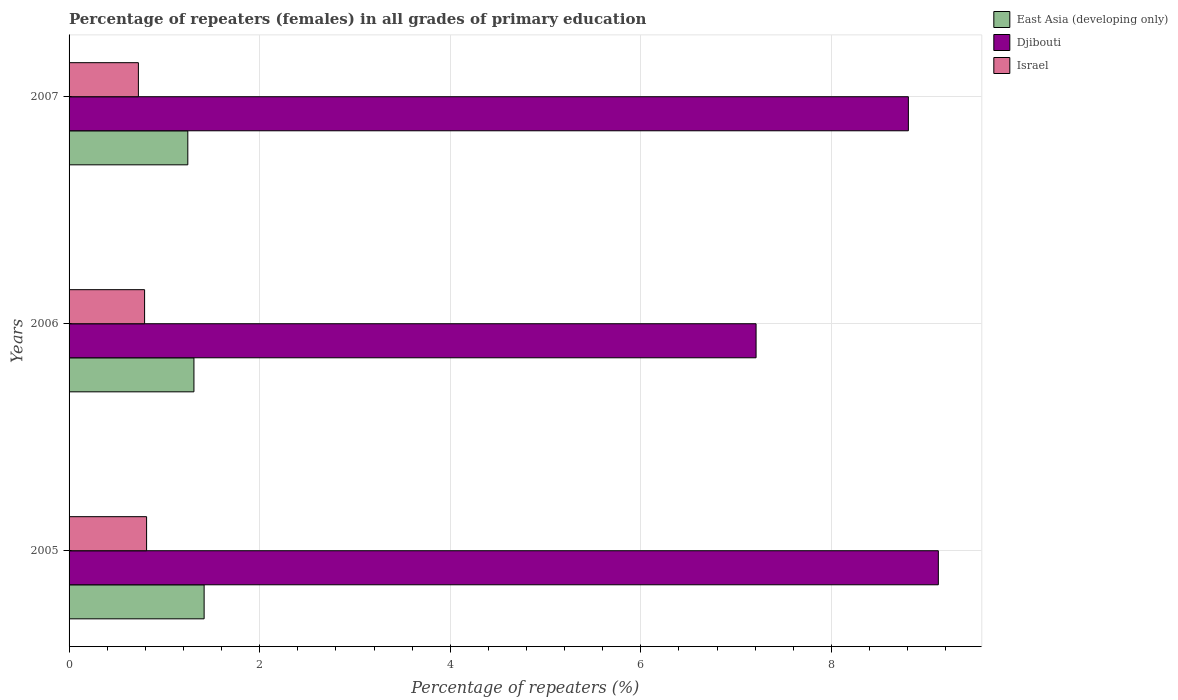How many different coloured bars are there?
Your response must be concise. 3. Are the number of bars per tick equal to the number of legend labels?
Give a very brief answer. Yes. How many bars are there on the 1st tick from the bottom?
Ensure brevity in your answer.  3. What is the percentage of repeaters (females) in Israel in 2007?
Your answer should be compact. 0.73. Across all years, what is the maximum percentage of repeaters (females) in East Asia (developing only)?
Provide a succinct answer. 1.42. Across all years, what is the minimum percentage of repeaters (females) in East Asia (developing only)?
Your answer should be very brief. 1.25. What is the total percentage of repeaters (females) in Djibouti in the graph?
Your answer should be very brief. 25.14. What is the difference between the percentage of repeaters (females) in Israel in 2005 and that in 2006?
Keep it short and to the point. 0.02. What is the difference between the percentage of repeaters (females) in East Asia (developing only) in 2006 and the percentage of repeaters (females) in Israel in 2005?
Your response must be concise. 0.5. What is the average percentage of repeaters (females) in Djibouti per year?
Make the answer very short. 8.38. In the year 2006, what is the difference between the percentage of repeaters (females) in Israel and percentage of repeaters (females) in Djibouti?
Give a very brief answer. -6.42. What is the ratio of the percentage of repeaters (females) in Israel in 2006 to that in 2007?
Offer a terse response. 1.09. Is the difference between the percentage of repeaters (females) in Israel in 2005 and 2006 greater than the difference between the percentage of repeaters (females) in Djibouti in 2005 and 2006?
Your answer should be compact. No. What is the difference between the highest and the second highest percentage of repeaters (females) in East Asia (developing only)?
Your response must be concise. 0.11. What is the difference between the highest and the lowest percentage of repeaters (females) in Israel?
Offer a terse response. 0.09. What does the 3rd bar from the top in 2007 represents?
Your answer should be compact. East Asia (developing only). What does the 2nd bar from the bottom in 2007 represents?
Keep it short and to the point. Djibouti. Are all the bars in the graph horizontal?
Provide a succinct answer. Yes. What is the difference between two consecutive major ticks on the X-axis?
Keep it short and to the point. 2. Are the values on the major ticks of X-axis written in scientific E-notation?
Ensure brevity in your answer.  No. Does the graph contain any zero values?
Make the answer very short. No. Does the graph contain grids?
Your answer should be very brief. Yes. Where does the legend appear in the graph?
Make the answer very short. Top right. How are the legend labels stacked?
Your answer should be very brief. Vertical. What is the title of the graph?
Your answer should be compact. Percentage of repeaters (females) in all grades of primary education. What is the label or title of the X-axis?
Your response must be concise. Percentage of repeaters (%). What is the label or title of the Y-axis?
Give a very brief answer. Years. What is the Percentage of repeaters (%) in East Asia (developing only) in 2005?
Make the answer very short. 1.42. What is the Percentage of repeaters (%) in Djibouti in 2005?
Offer a very short reply. 9.12. What is the Percentage of repeaters (%) of Israel in 2005?
Ensure brevity in your answer.  0.81. What is the Percentage of repeaters (%) of East Asia (developing only) in 2006?
Make the answer very short. 1.31. What is the Percentage of repeaters (%) of Djibouti in 2006?
Provide a succinct answer. 7.21. What is the Percentage of repeaters (%) in Israel in 2006?
Ensure brevity in your answer.  0.79. What is the Percentage of repeaters (%) in East Asia (developing only) in 2007?
Make the answer very short. 1.25. What is the Percentage of repeaters (%) in Djibouti in 2007?
Give a very brief answer. 8.81. What is the Percentage of repeaters (%) in Israel in 2007?
Offer a terse response. 0.73. Across all years, what is the maximum Percentage of repeaters (%) in East Asia (developing only)?
Make the answer very short. 1.42. Across all years, what is the maximum Percentage of repeaters (%) in Djibouti?
Make the answer very short. 9.12. Across all years, what is the maximum Percentage of repeaters (%) in Israel?
Your answer should be very brief. 0.81. Across all years, what is the minimum Percentage of repeaters (%) in East Asia (developing only)?
Your answer should be compact. 1.25. Across all years, what is the minimum Percentage of repeaters (%) in Djibouti?
Your response must be concise. 7.21. Across all years, what is the minimum Percentage of repeaters (%) in Israel?
Make the answer very short. 0.73. What is the total Percentage of repeaters (%) in East Asia (developing only) in the graph?
Give a very brief answer. 3.97. What is the total Percentage of repeaters (%) in Djibouti in the graph?
Offer a terse response. 25.14. What is the total Percentage of repeaters (%) of Israel in the graph?
Offer a very short reply. 2.33. What is the difference between the Percentage of repeaters (%) of East Asia (developing only) in 2005 and that in 2006?
Provide a short and direct response. 0.11. What is the difference between the Percentage of repeaters (%) in Djibouti in 2005 and that in 2006?
Offer a terse response. 1.91. What is the difference between the Percentage of repeaters (%) of Israel in 2005 and that in 2006?
Offer a very short reply. 0.02. What is the difference between the Percentage of repeaters (%) of East Asia (developing only) in 2005 and that in 2007?
Your answer should be compact. 0.17. What is the difference between the Percentage of repeaters (%) in Djibouti in 2005 and that in 2007?
Your answer should be very brief. 0.31. What is the difference between the Percentage of repeaters (%) of Israel in 2005 and that in 2007?
Your answer should be compact. 0.09. What is the difference between the Percentage of repeaters (%) of East Asia (developing only) in 2006 and that in 2007?
Your response must be concise. 0.06. What is the difference between the Percentage of repeaters (%) in Djibouti in 2006 and that in 2007?
Your answer should be very brief. -1.6. What is the difference between the Percentage of repeaters (%) in Israel in 2006 and that in 2007?
Provide a succinct answer. 0.07. What is the difference between the Percentage of repeaters (%) in East Asia (developing only) in 2005 and the Percentage of repeaters (%) in Djibouti in 2006?
Your answer should be very brief. -5.79. What is the difference between the Percentage of repeaters (%) in East Asia (developing only) in 2005 and the Percentage of repeaters (%) in Israel in 2006?
Keep it short and to the point. 0.62. What is the difference between the Percentage of repeaters (%) of Djibouti in 2005 and the Percentage of repeaters (%) of Israel in 2006?
Keep it short and to the point. 8.33. What is the difference between the Percentage of repeaters (%) in East Asia (developing only) in 2005 and the Percentage of repeaters (%) in Djibouti in 2007?
Offer a terse response. -7.39. What is the difference between the Percentage of repeaters (%) in East Asia (developing only) in 2005 and the Percentage of repeaters (%) in Israel in 2007?
Your answer should be compact. 0.69. What is the difference between the Percentage of repeaters (%) in Djibouti in 2005 and the Percentage of repeaters (%) in Israel in 2007?
Keep it short and to the point. 8.39. What is the difference between the Percentage of repeaters (%) in East Asia (developing only) in 2006 and the Percentage of repeaters (%) in Djibouti in 2007?
Your answer should be very brief. -7.5. What is the difference between the Percentage of repeaters (%) of East Asia (developing only) in 2006 and the Percentage of repeaters (%) of Israel in 2007?
Ensure brevity in your answer.  0.58. What is the difference between the Percentage of repeaters (%) of Djibouti in 2006 and the Percentage of repeaters (%) of Israel in 2007?
Make the answer very short. 6.48. What is the average Percentage of repeaters (%) in East Asia (developing only) per year?
Ensure brevity in your answer.  1.32. What is the average Percentage of repeaters (%) in Djibouti per year?
Your response must be concise. 8.38. What is the average Percentage of repeaters (%) in Israel per year?
Your response must be concise. 0.78. In the year 2005, what is the difference between the Percentage of repeaters (%) in East Asia (developing only) and Percentage of repeaters (%) in Djibouti?
Ensure brevity in your answer.  -7.71. In the year 2005, what is the difference between the Percentage of repeaters (%) in East Asia (developing only) and Percentage of repeaters (%) in Israel?
Provide a short and direct response. 0.6. In the year 2005, what is the difference between the Percentage of repeaters (%) of Djibouti and Percentage of repeaters (%) of Israel?
Provide a short and direct response. 8.31. In the year 2006, what is the difference between the Percentage of repeaters (%) in East Asia (developing only) and Percentage of repeaters (%) in Djibouti?
Ensure brevity in your answer.  -5.9. In the year 2006, what is the difference between the Percentage of repeaters (%) of East Asia (developing only) and Percentage of repeaters (%) of Israel?
Your response must be concise. 0.52. In the year 2006, what is the difference between the Percentage of repeaters (%) of Djibouti and Percentage of repeaters (%) of Israel?
Make the answer very short. 6.42. In the year 2007, what is the difference between the Percentage of repeaters (%) in East Asia (developing only) and Percentage of repeaters (%) in Djibouti?
Give a very brief answer. -7.56. In the year 2007, what is the difference between the Percentage of repeaters (%) of East Asia (developing only) and Percentage of repeaters (%) of Israel?
Offer a very short reply. 0.52. In the year 2007, what is the difference between the Percentage of repeaters (%) in Djibouti and Percentage of repeaters (%) in Israel?
Give a very brief answer. 8.08. What is the ratio of the Percentage of repeaters (%) in East Asia (developing only) in 2005 to that in 2006?
Offer a very short reply. 1.08. What is the ratio of the Percentage of repeaters (%) in Djibouti in 2005 to that in 2006?
Give a very brief answer. 1.27. What is the ratio of the Percentage of repeaters (%) of Israel in 2005 to that in 2006?
Offer a very short reply. 1.03. What is the ratio of the Percentage of repeaters (%) of East Asia (developing only) in 2005 to that in 2007?
Your answer should be very brief. 1.14. What is the ratio of the Percentage of repeaters (%) of Djibouti in 2005 to that in 2007?
Offer a very short reply. 1.04. What is the ratio of the Percentage of repeaters (%) of Israel in 2005 to that in 2007?
Make the answer very short. 1.12. What is the ratio of the Percentage of repeaters (%) of East Asia (developing only) in 2006 to that in 2007?
Offer a terse response. 1.05. What is the ratio of the Percentage of repeaters (%) of Djibouti in 2006 to that in 2007?
Make the answer very short. 0.82. What is the ratio of the Percentage of repeaters (%) of Israel in 2006 to that in 2007?
Your response must be concise. 1.09. What is the difference between the highest and the second highest Percentage of repeaters (%) in East Asia (developing only)?
Keep it short and to the point. 0.11. What is the difference between the highest and the second highest Percentage of repeaters (%) of Djibouti?
Your answer should be compact. 0.31. What is the difference between the highest and the second highest Percentage of repeaters (%) of Israel?
Offer a very short reply. 0.02. What is the difference between the highest and the lowest Percentage of repeaters (%) in East Asia (developing only)?
Offer a very short reply. 0.17. What is the difference between the highest and the lowest Percentage of repeaters (%) of Djibouti?
Give a very brief answer. 1.91. What is the difference between the highest and the lowest Percentage of repeaters (%) in Israel?
Keep it short and to the point. 0.09. 